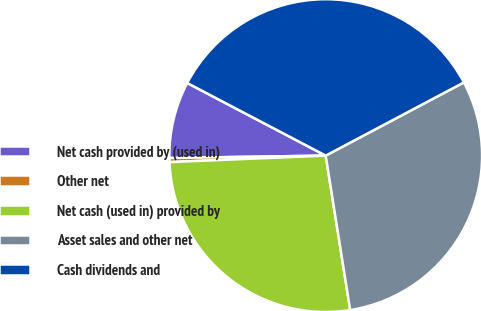Convert chart. <chart><loc_0><loc_0><loc_500><loc_500><pie_chart><fcel>Net cash provided by (used in)<fcel>Other net<fcel>Net cash (used in) provided by<fcel>Asset sales and other net<fcel>Cash dividends and<nl><fcel>7.93%<fcel>0.42%<fcel>26.84%<fcel>30.25%<fcel>34.56%<nl></chart> 